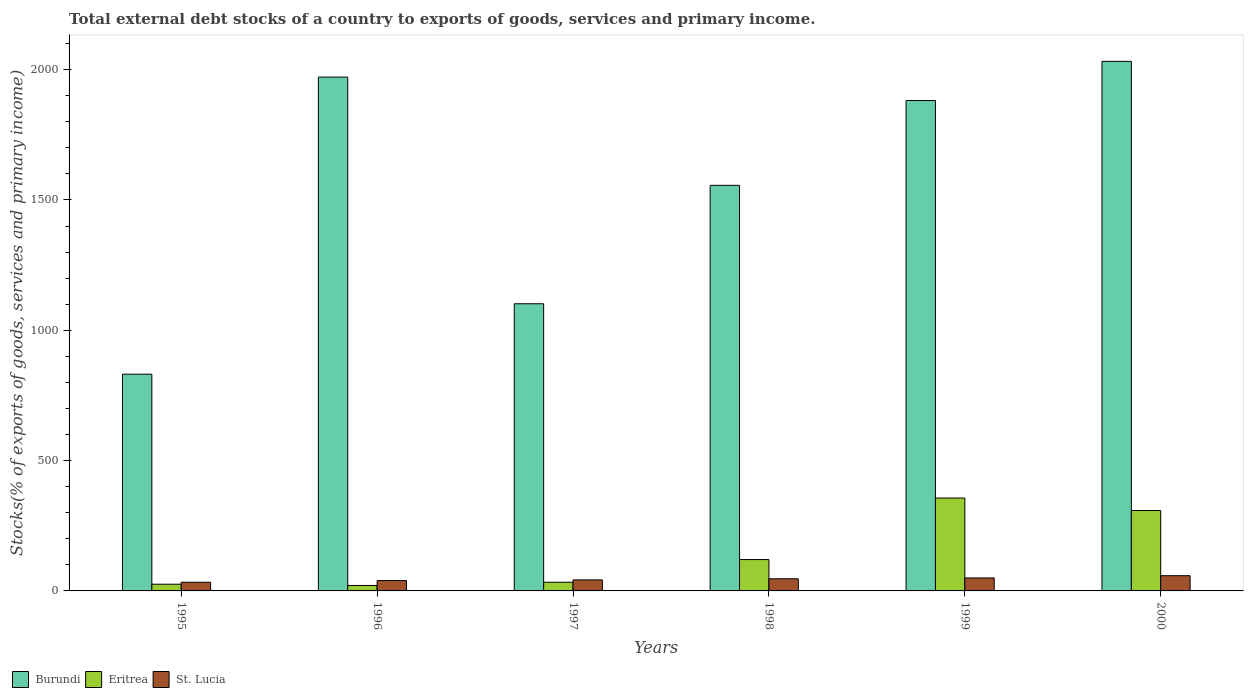How many different coloured bars are there?
Make the answer very short. 3. Are the number of bars on each tick of the X-axis equal?
Make the answer very short. Yes. What is the label of the 2nd group of bars from the left?
Provide a succinct answer. 1996. In how many cases, is the number of bars for a given year not equal to the number of legend labels?
Offer a terse response. 0. What is the total debt stocks in Eritrea in 1999?
Give a very brief answer. 356.4. Across all years, what is the maximum total debt stocks in Eritrea?
Provide a succinct answer. 356.4. Across all years, what is the minimum total debt stocks in Burundi?
Ensure brevity in your answer.  831.59. In which year was the total debt stocks in Eritrea maximum?
Keep it short and to the point. 1999. What is the total total debt stocks in Burundi in the graph?
Ensure brevity in your answer.  9374.53. What is the difference between the total debt stocks in Burundi in 1995 and that in 1999?
Offer a terse response. -1049.97. What is the difference between the total debt stocks in Eritrea in 1999 and the total debt stocks in Burundi in 1995?
Your answer should be very brief. -475.19. What is the average total debt stocks in Eritrea per year?
Your response must be concise. 144.22. In the year 1997, what is the difference between the total debt stocks in Burundi and total debt stocks in St. Lucia?
Your answer should be very brief. 1059.55. What is the ratio of the total debt stocks in Burundi in 1996 to that in 1999?
Your answer should be compact. 1.05. Is the total debt stocks in Eritrea in 1996 less than that in 1998?
Keep it short and to the point. Yes. What is the difference between the highest and the second highest total debt stocks in St. Lucia?
Your answer should be compact. 8.58. What is the difference between the highest and the lowest total debt stocks in St. Lucia?
Give a very brief answer. 25.11. Is the sum of the total debt stocks in Burundi in 1997 and 2000 greater than the maximum total debt stocks in Eritrea across all years?
Your answer should be compact. Yes. What does the 1st bar from the left in 2000 represents?
Your response must be concise. Burundi. What does the 2nd bar from the right in 1999 represents?
Provide a short and direct response. Eritrea. How many bars are there?
Provide a short and direct response. 18. Are all the bars in the graph horizontal?
Give a very brief answer. No. Are the values on the major ticks of Y-axis written in scientific E-notation?
Make the answer very short. No. Does the graph contain any zero values?
Your answer should be compact. No. Does the graph contain grids?
Ensure brevity in your answer.  No. How many legend labels are there?
Your answer should be very brief. 3. What is the title of the graph?
Make the answer very short. Total external debt stocks of a country to exports of goods, services and primary income. Does "Greenland" appear as one of the legend labels in the graph?
Keep it short and to the point. No. What is the label or title of the Y-axis?
Make the answer very short. Stocks(% of exports of goods, services and primary income). What is the Stocks(% of exports of goods, services and primary income) in Burundi in 1995?
Your answer should be very brief. 831.59. What is the Stocks(% of exports of goods, services and primary income) in Eritrea in 1995?
Keep it short and to the point. 25.77. What is the Stocks(% of exports of goods, services and primary income) in St. Lucia in 1995?
Keep it short and to the point. 33.28. What is the Stocks(% of exports of goods, services and primary income) in Burundi in 1996?
Provide a succinct answer. 1971.54. What is the Stocks(% of exports of goods, services and primary income) in Eritrea in 1996?
Your response must be concise. 20.97. What is the Stocks(% of exports of goods, services and primary income) of St. Lucia in 1996?
Your response must be concise. 39.71. What is the Stocks(% of exports of goods, services and primary income) of Burundi in 1997?
Your answer should be compact. 1101.81. What is the Stocks(% of exports of goods, services and primary income) in Eritrea in 1997?
Provide a succinct answer. 33.27. What is the Stocks(% of exports of goods, services and primary income) in St. Lucia in 1997?
Your response must be concise. 42.25. What is the Stocks(% of exports of goods, services and primary income) in Burundi in 1998?
Provide a succinct answer. 1556.17. What is the Stocks(% of exports of goods, services and primary income) in Eritrea in 1998?
Your answer should be very brief. 120.36. What is the Stocks(% of exports of goods, services and primary income) in St. Lucia in 1998?
Ensure brevity in your answer.  46.62. What is the Stocks(% of exports of goods, services and primary income) in Burundi in 1999?
Your response must be concise. 1881.55. What is the Stocks(% of exports of goods, services and primary income) of Eritrea in 1999?
Give a very brief answer. 356.4. What is the Stocks(% of exports of goods, services and primary income) in St. Lucia in 1999?
Offer a terse response. 49.81. What is the Stocks(% of exports of goods, services and primary income) in Burundi in 2000?
Give a very brief answer. 2031.87. What is the Stocks(% of exports of goods, services and primary income) in Eritrea in 2000?
Your response must be concise. 308.53. What is the Stocks(% of exports of goods, services and primary income) of St. Lucia in 2000?
Your answer should be compact. 58.4. Across all years, what is the maximum Stocks(% of exports of goods, services and primary income) of Burundi?
Ensure brevity in your answer.  2031.87. Across all years, what is the maximum Stocks(% of exports of goods, services and primary income) in Eritrea?
Your answer should be compact. 356.4. Across all years, what is the maximum Stocks(% of exports of goods, services and primary income) in St. Lucia?
Give a very brief answer. 58.4. Across all years, what is the minimum Stocks(% of exports of goods, services and primary income) in Burundi?
Your answer should be compact. 831.59. Across all years, what is the minimum Stocks(% of exports of goods, services and primary income) of Eritrea?
Offer a very short reply. 20.97. Across all years, what is the minimum Stocks(% of exports of goods, services and primary income) of St. Lucia?
Give a very brief answer. 33.28. What is the total Stocks(% of exports of goods, services and primary income) of Burundi in the graph?
Give a very brief answer. 9374.53. What is the total Stocks(% of exports of goods, services and primary income) in Eritrea in the graph?
Your response must be concise. 865.29. What is the total Stocks(% of exports of goods, services and primary income) in St. Lucia in the graph?
Your answer should be very brief. 270.07. What is the difference between the Stocks(% of exports of goods, services and primary income) of Burundi in 1995 and that in 1996?
Keep it short and to the point. -1139.95. What is the difference between the Stocks(% of exports of goods, services and primary income) of Eritrea in 1995 and that in 1996?
Your answer should be compact. 4.8. What is the difference between the Stocks(% of exports of goods, services and primary income) of St. Lucia in 1995 and that in 1996?
Make the answer very short. -6.43. What is the difference between the Stocks(% of exports of goods, services and primary income) in Burundi in 1995 and that in 1997?
Make the answer very short. -270.22. What is the difference between the Stocks(% of exports of goods, services and primary income) of Eritrea in 1995 and that in 1997?
Provide a short and direct response. -7.5. What is the difference between the Stocks(% of exports of goods, services and primary income) in St. Lucia in 1995 and that in 1997?
Offer a very short reply. -8.97. What is the difference between the Stocks(% of exports of goods, services and primary income) of Burundi in 1995 and that in 1998?
Give a very brief answer. -724.58. What is the difference between the Stocks(% of exports of goods, services and primary income) in Eritrea in 1995 and that in 1998?
Offer a very short reply. -94.6. What is the difference between the Stocks(% of exports of goods, services and primary income) in St. Lucia in 1995 and that in 1998?
Your answer should be compact. -13.34. What is the difference between the Stocks(% of exports of goods, services and primary income) in Burundi in 1995 and that in 1999?
Make the answer very short. -1049.97. What is the difference between the Stocks(% of exports of goods, services and primary income) of Eritrea in 1995 and that in 1999?
Your response must be concise. -330.63. What is the difference between the Stocks(% of exports of goods, services and primary income) in St. Lucia in 1995 and that in 1999?
Offer a terse response. -16.53. What is the difference between the Stocks(% of exports of goods, services and primary income) of Burundi in 1995 and that in 2000?
Keep it short and to the point. -1200.29. What is the difference between the Stocks(% of exports of goods, services and primary income) of Eritrea in 1995 and that in 2000?
Your response must be concise. -282.76. What is the difference between the Stocks(% of exports of goods, services and primary income) of St. Lucia in 1995 and that in 2000?
Your answer should be compact. -25.11. What is the difference between the Stocks(% of exports of goods, services and primary income) of Burundi in 1996 and that in 1997?
Keep it short and to the point. 869.73. What is the difference between the Stocks(% of exports of goods, services and primary income) of Eritrea in 1996 and that in 1997?
Ensure brevity in your answer.  -12.3. What is the difference between the Stocks(% of exports of goods, services and primary income) in St. Lucia in 1996 and that in 1997?
Make the answer very short. -2.54. What is the difference between the Stocks(% of exports of goods, services and primary income) in Burundi in 1996 and that in 1998?
Your answer should be compact. 415.36. What is the difference between the Stocks(% of exports of goods, services and primary income) in Eritrea in 1996 and that in 1998?
Ensure brevity in your answer.  -99.39. What is the difference between the Stocks(% of exports of goods, services and primary income) of St. Lucia in 1996 and that in 1998?
Your answer should be compact. -6.9. What is the difference between the Stocks(% of exports of goods, services and primary income) in Burundi in 1996 and that in 1999?
Your answer should be very brief. 89.98. What is the difference between the Stocks(% of exports of goods, services and primary income) of Eritrea in 1996 and that in 1999?
Offer a terse response. -335.43. What is the difference between the Stocks(% of exports of goods, services and primary income) in St. Lucia in 1996 and that in 1999?
Give a very brief answer. -10.1. What is the difference between the Stocks(% of exports of goods, services and primary income) in Burundi in 1996 and that in 2000?
Offer a terse response. -60.34. What is the difference between the Stocks(% of exports of goods, services and primary income) of Eritrea in 1996 and that in 2000?
Offer a very short reply. -287.56. What is the difference between the Stocks(% of exports of goods, services and primary income) in St. Lucia in 1996 and that in 2000?
Your answer should be very brief. -18.68. What is the difference between the Stocks(% of exports of goods, services and primary income) of Burundi in 1997 and that in 1998?
Provide a succinct answer. -454.36. What is the difference between the Stocks(% of exports of goods, services and primary income) in Eritrea in 1997 and that in 1998?
Your response must be concise. -87.09. What is the difference between the Stocks(% of exports of goods, services and primary income) in St. Lucia in 1997 and that in 1998?
Ensure brevity in your answer.  -4.36. What is the difference between the Stocks(% of exports of goods, services and primary income) in Burundi in 1997 and that in 1999?
Your answer should be compact. -779.75. What is the difference between the Stocks(% of exports of goods, services and primary income) in Eritrea in 1997 and that in 1999?
Make the answer very short. -323.12. What is the difference between the Stocks(% of exports of goods, services and primary income) of St. Lucia in 1997 and that in 1999?
Keep it short and to the point. -7.56. What is the difference between the Stocks(% of exports of goods, services and primary income) of Burundi in 1997 and that in 2000?
Give a very brief answer. -930.07. What is the difference between the Stocks(% of exports of goods, services and primary income) of Eritrea in 1997 and that in 2000?
Provide a succinct answer. -275.26. What is the difference between the Stocks(% of exports of goods, services and primary income) in St. Lucia in 1997 and that in 2000?
Offer a very short reply. -16.14. What is the difference between the Stocks(% of exports of goods, services and primary income) of Burundi in 1998 and that in 1999?
Provide a short and direct response. -325.38. What is the difference between the Stocks(% of exports of goods, services and primary income) of Eritrea in 1998 and that in 1999?
Offer a terse response. -236.03. What is the difference between the Stocks(% of exports of goods, services and primary income) in St. Lucia in 1998 and that in 1999?
Offer a terse response. -3.19. What is the difference between the Stocks(% of exports of goods, services and primary income) in Burundi in 1998 and that in 2000?
Provide a short and direct response. -475.7. What is the difference between the Stocks(% of exports of goods, services and primary income) in Eritrea in 1998 and that in 2000?
Your response must be concise. -188.17. What is the difference between the Stocks(% of exports of goods, services and primary income) of St. Lucia in 1998 and that in 2000?
Your response must be concise. -11.78. What is the difference between the Stocks(% of exports of goods, services and primary income) of Burundi in 1999 and that in 2000?
Provide a short and direct response. -150.32. What is the difference between the Stocks(% of exports of goods, services and primary income) in Eritrea in 1999 and that in 2000?
Provide a short and direct response. 47.86. What is the difference between the Stocks(% of exports of goods, services and primary income) in St. Lucia in 1999 and that in 2000?
Your answer should be compact. -8.58. What is the difference between the Stocks(% of exports of goods, services and primary income) in Burundi in 1995 and the Stocks(% of exports of goods, services and primary income) in Eritrea in 1996?
Offer a very short reply. 810.62. What is the difference between the Stocks(% of exports of goods, services and primary income) in Burundi in 1995 and the Stocks(% of exports of goods, services and primary income) in St. Lucia in 1996?
Your answer should be compact. 791.87. What is the difference between the Stocks(% of exports of goods, services and primary income) of Eritrea in 1995 and the Stocks(% of exports of goods, services and primary income) of St. Lucia in 1996?
Make the answer very short. -13.95. What is the difference between the Stocks(% of exports of goods, services and primary income) of Burundi in 1995 and the Stocks(% of exports of goods, services and primary income) of Eritrea in 1997?
Your answer should be very brief. 798.32. What is the difference between the Stocks(% of exports of goods, services and primary income) of Burundi in 1995 and the Stocks(% of exports of goods, services and primary income) of St. Lucia in 1997?
Offer a terse response. 789.33. What is the difference between the Stocks(% of exports of goods, services and primary income) in Eritrea in 1995 and the Stocks(% of exports of goods, services and primary income) in St. Lucia in 1997?
Offer a terse response. -16.49. What is the difference between the Stocks(% of exports of goods, services and primary income) in Burundi in 1995 and the Stocks(% of exports of goods, services and primary income) in Eritrea in 1998?
Provide a short and direct response. 711.22. What is the difference between the Stocks(% of exports of goods, services and primary income) in Burundi in 1995 and the Stocks(% of exports of goods, services and primary income) in St. Lucia in 1998?
Offer a very short reply. 784.97. What is the difference between the Stocks(% of exports of goods, services and primary income) in Eritrea in 1995 and the Stocks(% of exports of goods, services and primary income) in St. Lucia in 1998?
Your answer should be very brief. -20.85. What is the difference between the Stocks(% of exports of goods, services and primary income) in Burundi in 1995 and the Stocks(% of exports of goods, services and primary income) in Eritrea in 1999?
Your answer should be compact. 475.19. What is the difference between the Stocks(% of exports of goods, services and primary income) in Burundi in 1995 and the Stocks(% of exports of goods, services and primary income) in St. Lucia in 1999?
Provide a succinct answer. 781.78. What is the difference between the Stocks(% of exports of goods, services and primary income) of Eritrea in 1995 and the Stocks(% of exports of goods, services and primary income) of St. Lucia in 1999?
Make the answer very short. -24.04. What is the difference between the Stocks(% of exports of goods, services and primary income) in Burundi in 1995 and the Stocks(% of exports of goods, services and primary income) in Eritrea in 2000?
Your response must be concise. 523.06. What is the difference between the Stocks(% of exports of goods, services and primary income) in Burundi in 1995 and the Stocks(% of exports of goods, services and primary income) in St. Lucia in 2000?
Provide a short and direct response. 773.19. What is the difference between the Stocks(% of exports of goods, services and primary income) of Eritrea in 1995 and the Stocks(% of exports of goods, services and primary income) of St. Lucia in 2000?
Your answer should be compact. -32.63. What is the difference between the Stocks(% of exports of goods, services and primary income) in Burundi in 1996 and the Stocks(% of exports of goods, services and primary income) in Eritrea in 1997?
Your answer should be very brief. 1938.26. What is the difference between the Stocks(% of exports of goods, services and primary income) of Burundi in 1996 and the Stocks(% of exports of goods, services and primary income) of St. Lucia in 1997?
Provide a short and direct response. 1929.28. What is the difference between the Stocks(% of exports of goods, services and primary income) of Eritrea in 1996 and the Stocks(% of exports of goods, services and primary income) of St. Lucia in 1997?
Give a very brief answer. -21.28. What is the difference between the Stocks(% of exports of goods, services and primary income) in Burundi in 1996 and the Stocks(% of exports of goods, services and primary income) in Eritrea in 1998?
Ensure brevity in your answer.  1851.17. What is the difference between the Stocks(% of exports of goods, services and primary income) of Burundi in 1996 and the Stocks(% of exports of goods, services and primary income) of St. Lucia in 1998?
Offer a very short reply. 1924.92. What is the difference between the Stocks(% of exports of goods, services and primary income) of Eritrea in 1996 and the Stocks(% of exports of goods, services and primary income) of St. Lucia in 1998?
Ensure brevity in your answer.  -25.65. What is the difference between the Stocks(% of exports of goods, services and primary income) of Burundi in 1996 and the Stocks(% of exports of goods, services and primary income) of Eritrea in 1999?
Provide a short and direct response. 1615.14. What is the difference between the Stocks(% of exports of goods, services and primary income) of Burundi in 1996 and the Stocks(% of exports of goods, services and primary income) of St. Lucia in 1999?
Provide a short and direct response. 1921.72. What is the difference between the Stocks(% of exports of goods, services and primary income) in Eritrea in 1996 and the Stocks(% of exports of goods, services and primary income) in St. Lucia in 1999?
Your response must be concise. -28.84. What is the difference between the Stocks(% of exports of goods, services and primary income) in Burundi in 1996 and the Stocks(% of exports of goods, services and primary income) in Eritrea in 2000?
Offer a terse response. 1663. What is the difference between the Stocks(% of exports of goods, services and primary income) in Burundi in 1996 and the Stocks(% of exports of goods, services and primary income) in St. Lucia in 2000?
Provide a short and direct response. 1913.14. What is the difference between the Stocks(% of exports of goods, services and primary income) of Eritrea in 1996 and the Stocks(% of exports of goods, services and primary income) of St. Lucia in 2000?
Your answer should be compact. -37.43. What is the difference between the Stocks(% of exports of goods, services and primary income) of Burundi in 1997 and the Stocks(% of exports of goods, services and primary income) of Eritrea in 1998?
Provide a short and direct response. 981.44. What is the difference between the Stocks(% of exports of goods, services and primary income) of Burundi in 1997 and the Stocks(% of exports of goods, services and primary income) of St. Lucia in 1998?
Provide a succinct answer. 1055.19. What is the difference between the Stocks(% of exports of goods, services and primary income) of Eritrea in 1997 and the Stocks(% of exports of goods, services and primary income) of St. Lucia in 1998?
Make the answer very short. -13.35. What is the difference between the Stocks(% of exports of goods, services and primary income) of Burundi in 1997 and the Stocks(% of exports of goods, services and primary income) of Eritrea in 1999?
Your answer should be very brief. 745.41. What is the difference between the Stocks(% of exports of goods, services and primary income) of Burundi in 1997 and the Stocks(% of exports of goods, services and primary income) of St. Lucia in 1999?
Provide a succinct answer. 1052. What is the difference between the Stocks(% of exports of goods, services and primary income) of Eritrea in 1997 and the Stocks(% of exports of goods, services and primary income) of St. Lucia in 1999?
Ensure brevity in your answer.  -16.54. What is the difference between the Stocks(% of exports of goods, services and primary income) in Burundi in 1997 and the Stocks(% of exports of goods, services and primary income) in Eritrea in 2000?
Your answer should be very brief. 793.28. What is the difference between the Stocks(% of exports of goods, services and primary income) in Burundi in 1997 and the Stocks(% of exports of goods, services and primary income) in St. Lucia in 2000?
Ensure brevity in your answer.  1043.41. What is the difference between the Stocks(% of exports of goods, services and primary income) in Eritrea in 1997 and the Stocks(% of exports of goods, services and primary income) in St. Lucia in 2000?
Offer a terse response. -25.12. What is the difference between the Stocks(% of exports of goods, services and primary income) in Burundi in 1998 and the Stocks(% of exports of goods, services and primary income) in Eritrea in 1999?
Ensure brevity in your answer.  1199.78. What is the difference between the Stocks(% of exports of goods, services and primary income) of Burundi in 1998 and the Stocks(% of exports of goods, services and primary income) of St. Lucia in 1999?
Ensure brevity in your answer.  1506.36. What is the difference between the Stocks(% of exports of goods, services and primary income) of Eritrea in 1998 and the Stocks(% of exports of goods, services and primary income) of St. Lucia in 1999?
Offer a terse response. 70.55. What is the difference between the Stocks(% of exports of goods, services and primary income) of Burundi in 1998 and the Stocks(% of exports of goods, services and primary income) of Eritrea in 2000?
Provide a succinct answer. 1247.64. What is the difference between the Stocks(% of exports of goods, services and primary income) in Burundi in 1998 and the Stocks(% of exports of goods, services and primary income) in St. Lucia in 2000?
Your answer should be compact. 1497.78. What is the difference between the Stocks(% of exports of goods, services and primary income) in Eritrea in 1998 and the Stocks(% of exports of goods, services and primary income) in St. Lucia in 2000?
Offer a terse response. 61.97. What is the difference between the Stocks(% of exports of goods, services and primary income) of Burundi in 1999 and the Stocks(% of exports of goods, services and primary income) of Eritrea in 2000?
Your response must be concise. 1573.02. What is the difference between the Stocks(% of exports of goods, services and primary income) in Burundi in 1999 and the Stocks(% of exports of goods, services and primary income) in St. Lucia in 2000?
Offer a terse response. 1823.16. What is the difference between the Stocks(% of exports of goods, services and primary income) of Eritrea in 1999 and the Stocks(% of exports of goods, services and primary income) of St. Lucia in 2000?
Give a very brief answer. 298. What is the average Stocks(% of exports of goods, services and primary income) in Burundi per year?
Your answer should be compact. 1562.42. What is the average Stocks(% of exports of goods, services and primary income) in Eritrea per year?
Provide a short and direct response. 144.22. What is the average Stocks(% of exports of goods, services and primary income) of St. Lucia per year?
Offer a terse response. 45.01. In the year 1995, what is the difference between the Stocks(% of exports of goods, services and primary income) in Burundi and Stocks(% of exports of goods, services and primary income) in Eritrea?
Offer a terse response. 805.82. In the year 1995, what is the difference between the Stocks(% of exports of goods, services and primary income) in Burundi and Stocks(% of exports of goods, services and primary income) in St. Lucia?
Offer a terse response. 798.31. In the year 1995, what is the difference between the Stocks(% of exports of goods, services and primary income) of Eritrea and Stocks(% of exports of goods, services and primary income) of St. Lucia?
Provide a short and direct response. -7.51. In the year 1996, what is the difference between the Stocks(% of exports of goods, services and primary income) in Burundi and Stocks(% of exports of goods, services and primary income) in Eritrea?
Give a very brief answer. 1950.57. In the year 1996, what is the difference between the Stocks(% of exports of goods, services and primary income) of Burundi and Stocks(% of exports of goods, services and primary income) of St. Lucia?
Provide a short and direct response. 1931.82. In the year 1996, what is the difference between the Stocks(% of exports of goods, services and primary income) in Eritrea and Stocks(% of exports of goods, services and primary income) in St. Lucia?
Give a very brief answer. -18.75. In the year 1997, what is the difference between the Stocks(% of exports of goods, services and primary income) in Burundi and Stocks(% of exports of goods, services and primary income) in Eritrea?
Give a very brief answer. 1068.54. In the year 1997, what is the difference between the Stocks(% of exports of goods, services and primary income) of Burundi and Stocks(% of exports of goods, services and primary income) of St. Lucia?
Offer a terse response. 1059.55. In the year 1997, what is the difference between the Stocks(% of exports of goods, services and primary income) in Eritrea and Stocks(% of exports of goods, services and primary income) in St. Lucia?
Ensure brevity in your answer.  -8.98. In the year 1998, what is the difference between the Stocks(% of exports of goods, services and primary income) of Burundi and Stocks(% of exports of goods, services and primary income) of Eritrea?
Your answer should be compact. 1435.81. In the year 1998, what is the difference between the Stocks(% of exports of goods, services and primary income) of Burundi and Stocks(% of exports of goods, services and primary income) of St. Lucia?
Your answer should be very brief. 1509.55. In the year 1998, what is the difference between the Stocks(% of exports of goods, services and primary income) of Eritrea and Stocks(% of exports of goods, services and primary income) of St. Lucia?
Offer a very short reply. 73.75. In the year 1999, what is the difference between the Stocks(% of exports of goods, services and primary income) in Burundi and Stocks(% of exports of goods, services and primary income) in Eritrea?
Provide a succinct answer. 1525.16. In the year 1999, what is the difference between the Stocks(% of exports of goods, services and primary income) in Burundi and Stocks(% of exports of goods, services and primary income) in St. Lucia?
Give a very brief answer. 1831.74. In the year 1999, what is the difference between the Stocks(% of exports of goods, services and primary income) in Eritrea and Stocks(% of exports of goods, services and primary income) in St. Lucia?
Your answer should be very brief. 306.58. In the year 2000, what is the difference between the Stocks(% of exports of goods, services and primary income) in Burundi and Stocks(% of exports of goods, services and primary income) in Eritrea?
Offer a very short reply. 1723.34. In the year 2000, what is the difference between the Stocks(% of exports of goods, services and primary income) of Burundi and Stocks(% of exports of goods, services and primary income) of St. Lucia?
Your answer should be very brief. 1973.48. In the year 2000, what is the difference between the Stocks(% of exports of goods, services and primary income) of Eritrea and Stocks(% of exports of goods, services and primary income) of St. Lucia?
Give a very brief answer. 250.14. What is the ratio of the Stocks(% of exports of goods, services and primary income) of Burundi in 1995 to that in 1996?
Your answer should be very brief. 0.42. What is the ratio of the Stocks(% of exports of goods, services and primary income) of Eritrea in 1995 to that in 1996?
Your answer should be compact. 1.23. What is the ratio of the Stocks(% of exports of goods, services and primary income) in St. Lucia in 1995 to that in 1996?
Your answer should be compact. 0.84. What is the ratio of the Stocks(% of exports of goods, services and primary income) of Burundi in 1995 to that in 1997?
Provide a short and direct response. 0.75. What is the ratio of the Stocks(% of exports of goods, services and primary income) in Eritrea in 1995 to that in 1997?
Ensure brevity in your answer.  0.77. What is the ratio of the Stocks(% of exports of goods, services and primary income) in St. Lucia in 1995 to that in 1997?
Give a very brief answer. 0.79. What is the ratio of the Stocks(% of exports of goods, services and primary income) in Burundi in 1995 to that in 1998?
Make the answer very short. 0.53. What is the ratio of the Stocks(% of exports of goods, services and primary income) in Eritrea in 1995 to that in 1998?
Provide a succinct answer. 0.21. What is the ratio of the Stocks(% of exports of goods, services and primary income) of St. Lucia in 1995 to that in 1998?
Provide a short and direct response. 0.71. What is the ratio of the Stocks(% of exports of goods, services and primary income) in Burundi in 1995 to that in 1999?
Provide a succinct answer. 0.44. What is the ratio of the Stocks(% of exports of goods, services and primary income) of Eritrea in 1995 to that in 1999?
Offer a terse response. 0.07. What is the ratio of the Stocks(% of exports of goods, services and primary income) in St. Lucia in 1995 to that in 1999?
Offer a terse response. 0.67. What is the ratio of the Stocks(% of exports of goods, services and primary income) in Burundi in 1995 to that in 2000?
Your answer should be very brief. 0.41. What is the ratio of the Stocks(% of exports of goods, services and primary income) in Eritrea in 1995 to that in 2000?
Your response must be concise. 0.08. What is the ratio of the Stocks(% of exports of goods, services and primary income) in St. Lucia in 1995 to that in 2000?
Provide a short and direct response. 0.57. What is the ratio of the Stocks(% of exports of goods, services and primary income) in Burundi in 1996 to that in 1997?
Your response must be concise. 1.79. What is the ratio of the Stocks(% of exports of goods, services and primary income) of Eritrea in 1996 to that in 1997?
Your answer should be compact. 0.63. What is the ratio of the Stocks(% of exports of goods, services and primary income) in St. Lucia in 1996 to that in 1997?
Provide a short and direct response. 0.94. What is the ratio of the Stocks(% of exports of goods, services and primary income) of Burundi in 1996 to that in 1998?
Offer a terse response. 1.27. What is the ratio of the Stocks(% of exports of goods, services and primary income) of Eritrea in 1996 to that in 1998?
Offer a very short reply. 0.17. What is the ratio of the Stocks(% of exports of goods, services and primary income) of St. Lucia in 1996 to that in 1998?
Your response must be concise. 0.85. What is the ratio of the Stocks(% of exports of goods, services and primary income) of Burundi in 1996 to that in 1999?
Your answer should be very brief. 1.05. What is the ratio of the Stocks(% of exports of goods, services and primary income) in Eritrea in 1996 to that in 1999?
Make the answer very short. 0.06. What is the ratio of the Stocks(% of exports of goods, services and primary income) in St. Lucia in 1996 to that in 1999?
Offer a terse response. 0.8. What is the ratio of the Stocks(% of exports of goods, services and primary income) of Burundi in 1996 to that in 2000?
Ensure brevity in your answer.  0.97. What is the ratio of the Stocks(% of exports of goods, services and primary income) of Eritrea in 1996 to that in 2000?
Your answer should be compact. 0.07. What is the ratio of the Stocks(% of exports of goods, services and primary income) in St. Lucia in 1996 to that in 2000?
Provide a succinct answer. 0.68. What is the ratio of the Stocks(% of exports of goods, services and primary income) of Burundi in 1997 to that in 1998?
Provide a succinct answer. 0.71. What is the ratio of the Stocks(% of exports of goods, services and primary income) of Eritrea in 1997 to that in 1998?
Offer a very short reply. 0.28. What is the ratio of the Stocks(% of exports of goods, services and primary income) of St. Lucia in 1997 to that in 1998?
Give a very brief answer. 0.91. What is the ratio of the Stocks(% of exports of goods, services and primary income) of Burundi in 1997 to that in 1999?
Your answer should be compact. 0.59. What is the ratio of the Stocks(% of exports of goods, services and primary income) in Eritrea in 1997 to that in 1999?
Your answer should be compact. 0.09. What is the ratio of the Stocks(% of exports of goods, services and primary income) of St. Lucia in 1997 to that in 1999?
Make the answer very short. 0.85. What is the ratio of the Stocks(% of exports of goods, services and primary income) in Burundi in 1997 to that in 2000?
Offer a very short reply. 0.54. What is the ratio of the Stocks(% of exports of goods, services and primary income) in Eritrea in 1997 to that in 2000?
Your answer should be very brief. 0.11. What is the ratio of the Stocks(% of exports of goods, services and primary income) of St. Lucia in 1997 to that in 2000?
Offer a terse response. 0.72. What is the ratio of the Stocks(% of exports of goods, services and primary income) of Burundi in 1998 to that in 1999?
Your response must be concise. 0.83. What is the ratio of the Stocks(% of exports of goods, services and primary income) of Eritrea in 1998 to that in 1999?
Your answer should be very brief. 0.34. What is the ratio of the Stocks(% of exports of goods, services and primary income) in St. Lucia in 1998 to that in 1999?
Offer a very short reply. 0.94. What is the ratio of the Stocks(% of exports of goods, services and primary income) in Burundi in 1998 to that in 2000?
Your answer should be very brief. 0.77. What is the ratio of the Stocks(% of exports of goods, services and primary income) of Eritrea in 1998 to that in 2000?
Ensure brevity in your answer.  0.39. What is the ratio of the Stocks(% of exports of goods, services and primary income) in St. Lucia in 1998 to that in 2000?
Offer a very short reply. 0.8. What is the ratio of the Stocks(% of exports of goods, services and primary income) in Burundi in 1999 to that in 2000?
Provide a succinct answer. 0.93. What is the ratio of the Stocks(% of exports of goods, services and primary income) in Eritrea in 1999 to that in 2000?
Provide a succinct answer. 1.16. What is the ratio of the Stocks(% of exports of goods, services and primary income) in St. Lucia in 1999 to that in 2000?
Your answer should be compact. 0.85. What is the difference between the highest and the second highest Stocks(% of exports of goods, services and primary income) of Burundi?
Your response must be concise. 60.34. What is the difference between the highest and the second highest Stocks(% of exports of goods, services and primary income) in Eritrea?
Your answer should be very brief. 47.86. What is the difference between the highest and the second highest Stocks(% of exports of goods, services and primary income) of St. Lucia?
Provide a short and direct response. 8.58. What is the difference between the highest and the lowest Stocks(% of exports of goods, services and primary income) of Burundi?
Ensure brevity in your answer.  1200.29. What is the difference between the highest and the lowest Stocks(% of exports of goods, services and primary income) of Eritrea?
Ensure brevity in your answer.  335.43. What is the difference between the highest and the lowest Stocks(% of exports of goods, services and primary income) of St. Lucia?
Ensure brevity in your answer.  25.11. 